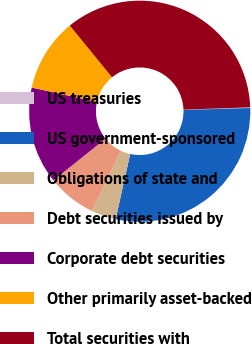Convert chart. <chart><loc_0><loc_0><loc_500><loc_500><pie_chart><fcel>US treasuries<fcel>US government-sponsored<fcel>Obligations of state and<fcel>Debt securities issued by<fcel>Corporate debt securities<fcel>Other primarily asset-backed<fcel>Total securities with<nl><fcel>0.1%<fcel>28.96%<fcel>3.62%<fcel>7.14%<fcel>14.19%<fcel>10.67%<fcel>35.33%<nl></chart> 